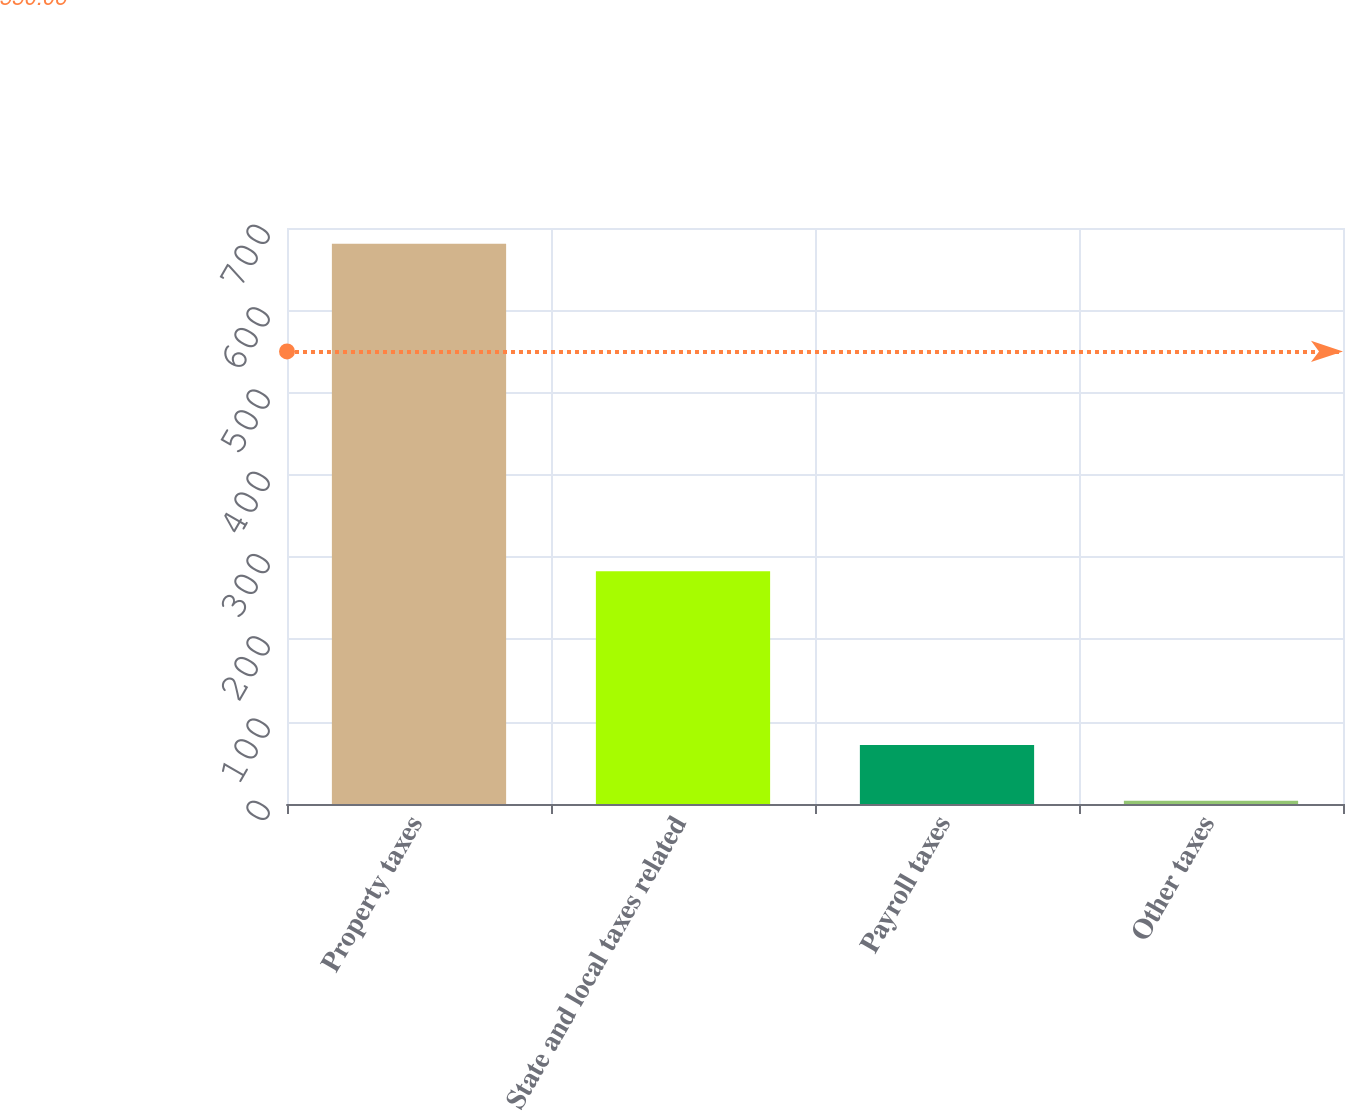<chart> <loc_0><loc_0><loc_500><loc_500><bar_chart><fcel>Property taxes<fcel>State and local taxes related<fcel>Payroll taxes<fcel>Other taxes<nl><fcel>681<fcel>283<fcel>71.7<fcel>4<nl></chart> 